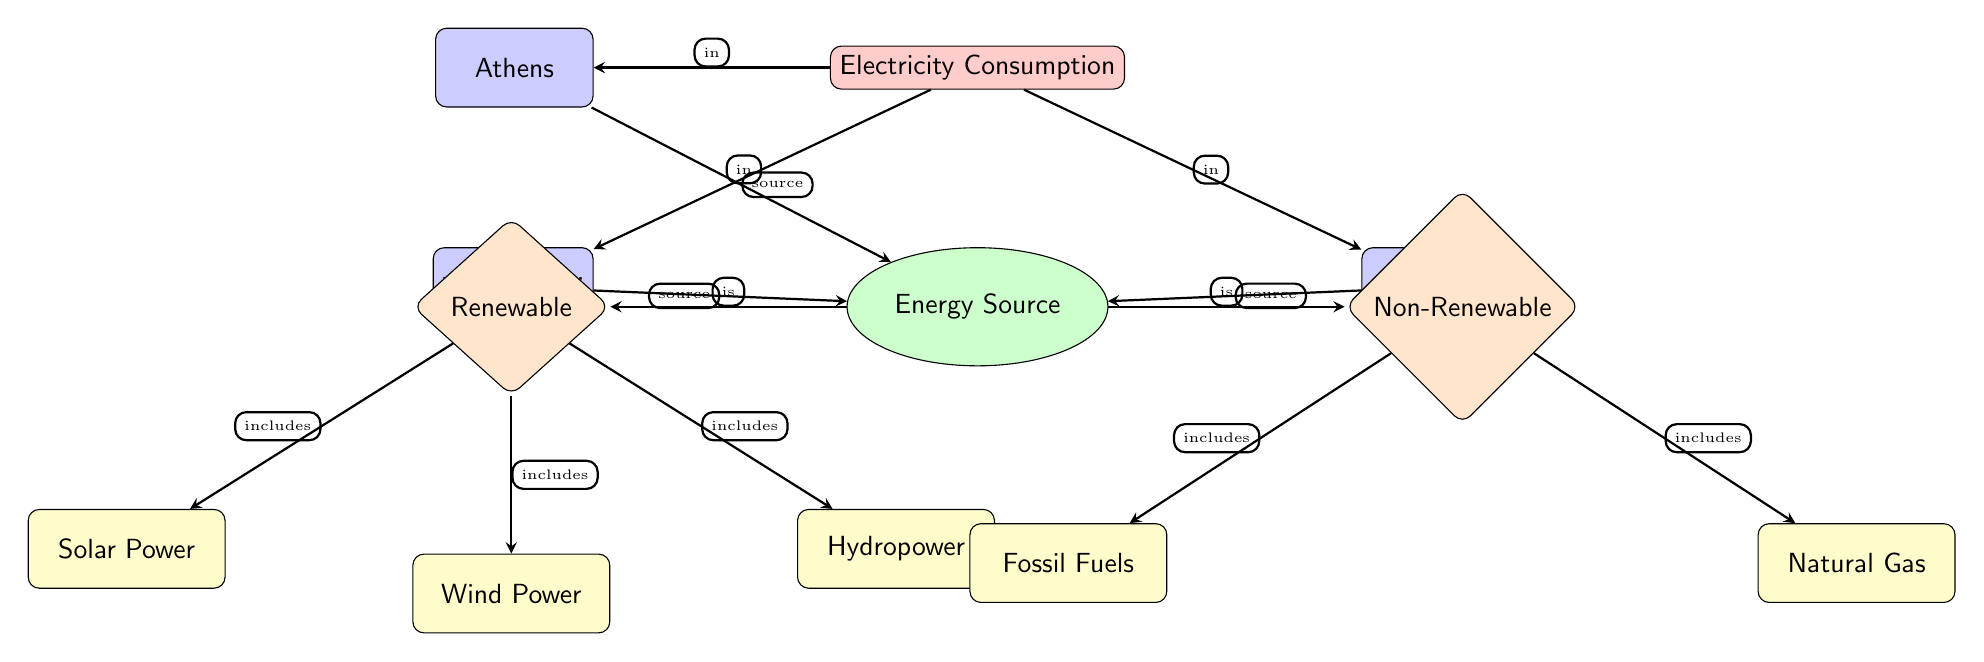What cities are shown in the diagram? The diagram lists three cities: Athens, Thessaloniki, and Patras. They are represented as nodes connected to the electricity consumption node, indicating their involvement in energy consumption.
Answer: Athens, Thessaloniki, Patras How many energy types are included in the diagram? There are two main energy types represented: Renewable and Non-Renewable. Each of these types is connected to various energy sources, making them distinct categories in the diagram.
Answer: 2 What renewable energy sources are represented? The renewable energy sources listed in the diagram are Solar Power, Wind Power, and Hydropower. These are shown as sub-nodes connected to the Renewable energy type.
Answer: Solar Power, Wind Power, Hydropower Which city has a connection to the electricity consumption node? All three cities (Athens, Thessaloniki, and Patras) have direct connections to the electricity consumption node, indicating that they consume electricity. The arrows direct towards them from the consumption node.
Answer: Athens, Thessaloniki, Patras What is the relationship between Renewable energy and its sources? The Renewable energy type 'includes' three sources: Solar Power, Wind Power, and Hydropower, as indicated by the arrows showing the connections from Renewable to these sources.
Answer: includes 